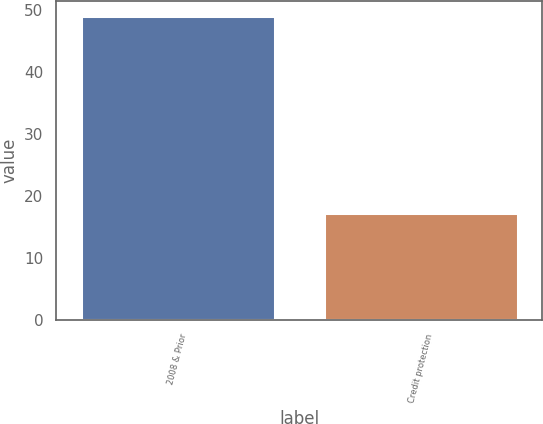Convert chart. <chart><loc_0><loc_0><loc_500><loc_500><bar_chart><fcel>2008 & Prior<fcel>Credit protection<nl><fcel>49<fcel>17.2<nl></chart> 